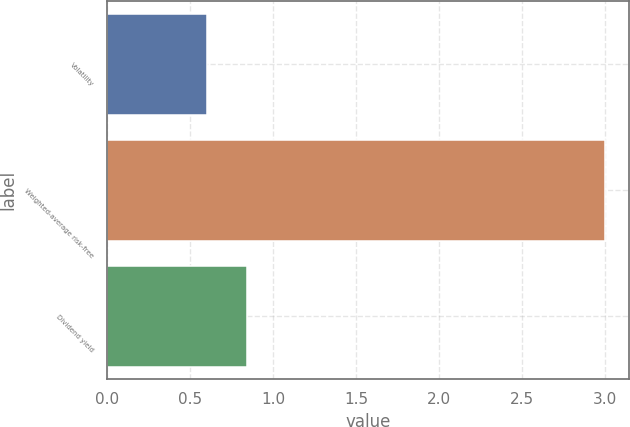<chart> <loc_0><loc_0><loc_500><loc_500><bar_chart><fcel>Volatility<fcel>Weighted-average risk-free<fcel>Dividend yield<nl><fcel>0.6<fcel>3<fcel>0.84<nl></chart> 